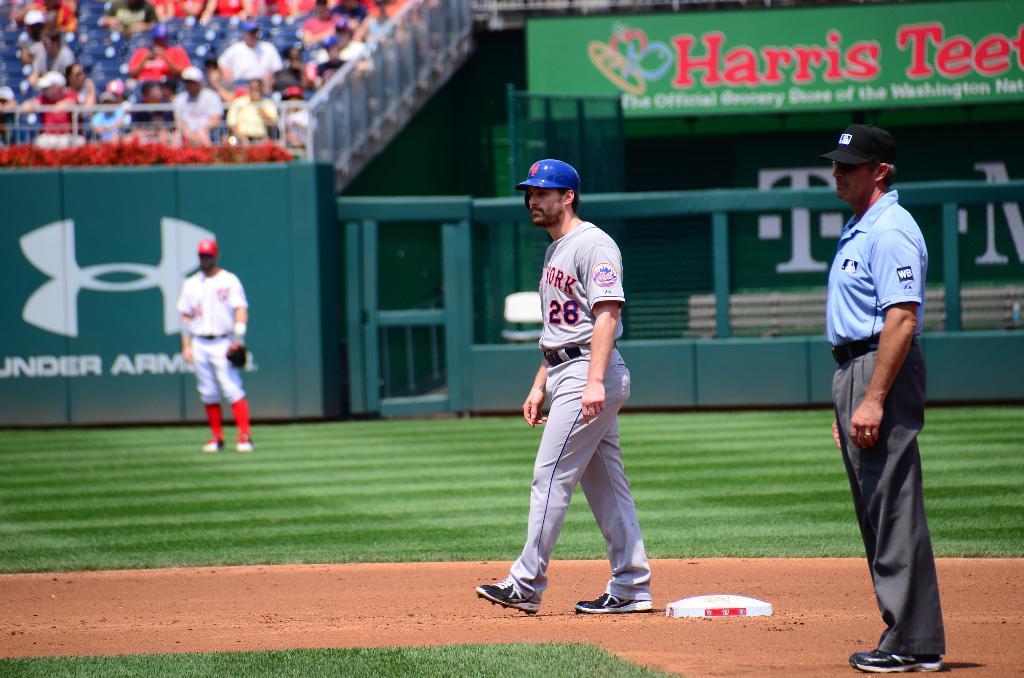Who is sponsoring this stadium?
Your answer should be compact. Under armour. What player number is on the base?
Make the answer very short. 28. 